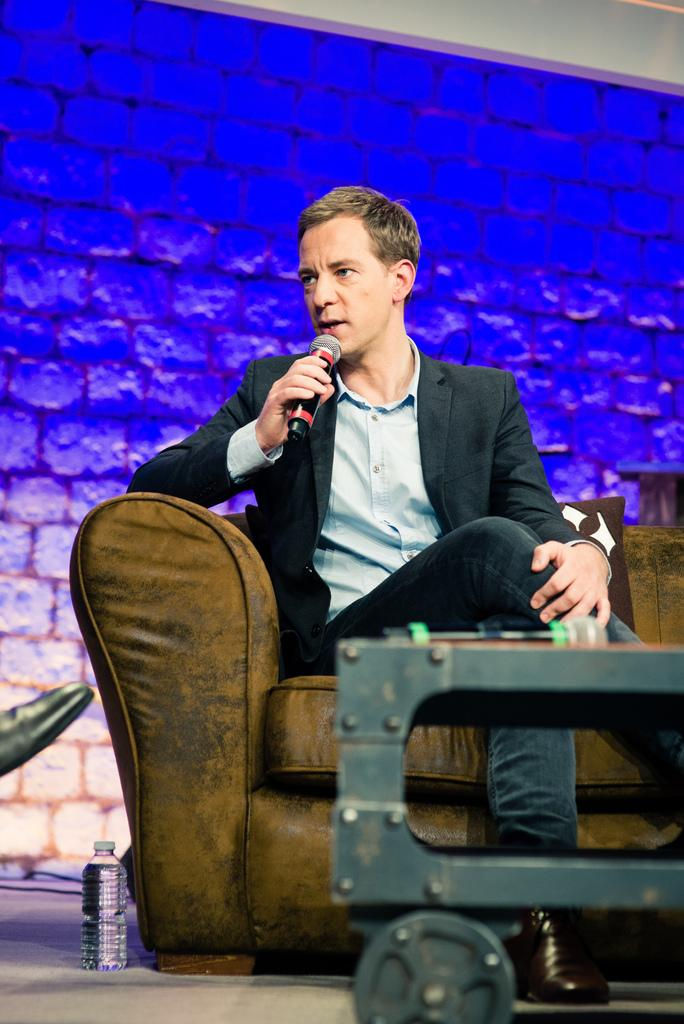What is the man in the image doing? The man is sitting on a couch in the center of the image and holding a microphone. What is in front of the couch? There is a table in front of the couch. What can be seen in the background of the image? There is a brick wall and a water bottle in the background of the image. How many pigs are visible in the image? There are no pigs present in the image. What type of lamp is on the table in the image? There is no lamp present on the table in the image. 